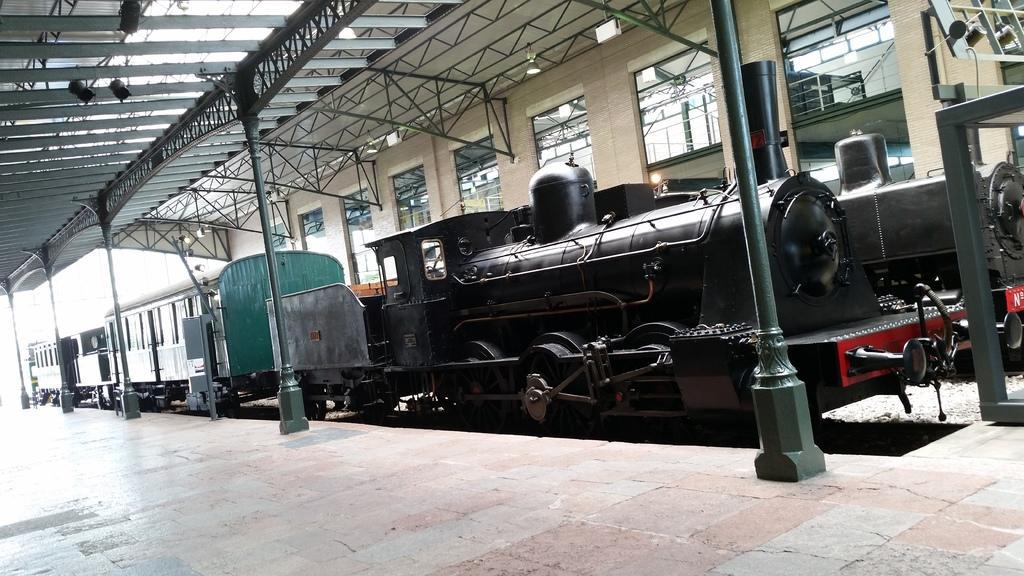How would you summarize this image in a sentence or two? In this image I can see a train on the track, pillars, windows and a rooftop. This image is taken may be on the platform. 